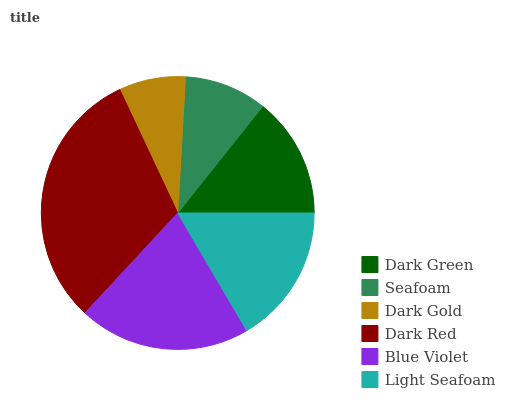Is Dark Gold the minimum?
Answer yes or no. Yes. Is Dark Red the maximum?
Answer yes or no. Yes. Is Seafoam the minimum?
Answer yes or no. No. Is Seafoam the maximum?
Answer yes or no. No. Is Dark Green greater than Seafoam?
Answer yes or no. Yes. Is Seafoam less than Dark Green?
Answer yes or no. Yes. Is Seafoam greater than Dark Green?
Answer yes or no. No. Is Dark Green less than Seafoam?
Answer yes or no. No. Is Light Seafoam the high median?
Answer yes or no. Yes. Is Dark Green the low median?
Answer yes or no. Yes. Is Seafoam the high median?
Answer yes or no. No. Is Seafoam the low median?
Answer yes or no. No. 